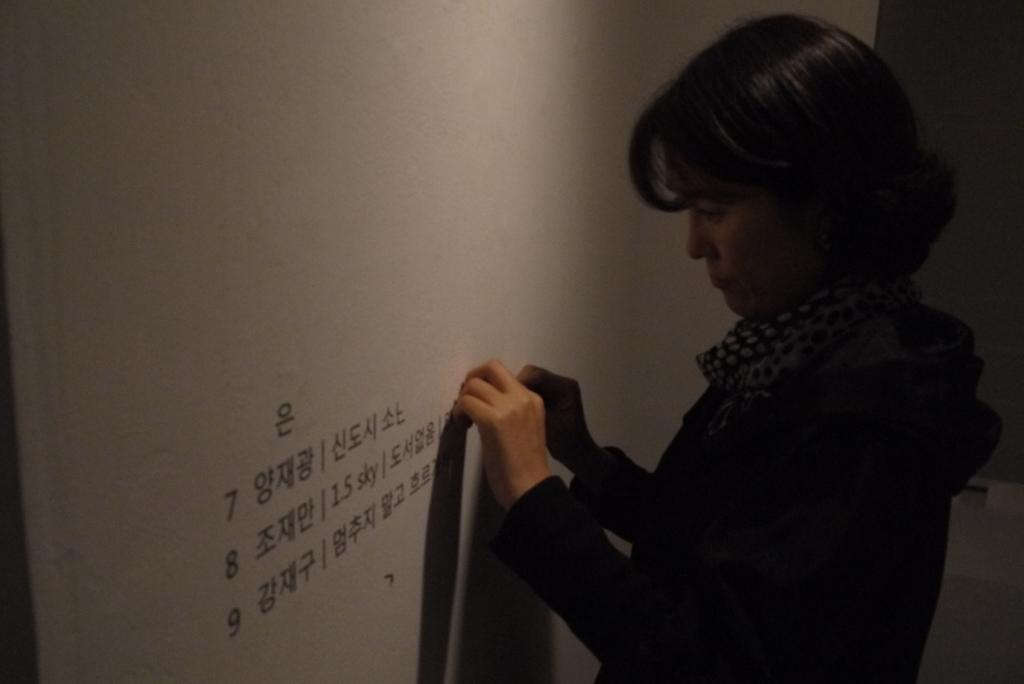Who is the main subject in the image? There is a woman in the image. Where is the woman located in the image? The woman is on the right side of the image. What is the woman doing in the image? The woman is pasting stickers on a wall. Can you describe the wall in the image? The wall is in front of the woman. What type of sea creature can be seen swimming near the woman in the image? There is no sea creature present in the image; it features a woman pasting stickers on a wall. What shape is the square that the woman is drawing on the wall? There is no square being drawn in the image; the woman is pasting stickers on the wall. 